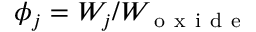Convert formula to latex. <formula><loc_0><loc_0><loc_500><loc_500>\phi _ { j } = W _ { j } / W _ { o x i d e }</formula> 